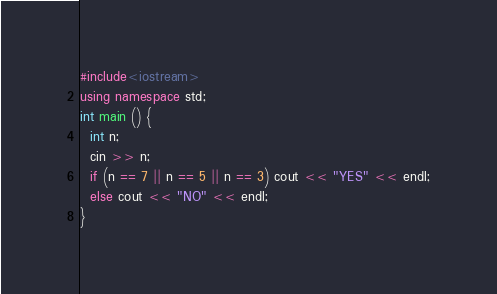Convert code to text. <code><loc_0><loc_0><loc_500><loc_500><_C++_>#include<iostream>
using namespace std;
int main () {
  int n;
  cin >> n;
  if (n == 7 || n == 5 || n == 3) cout << "YES" << endl;
  else cout << "NO" << endl;
}</code> 